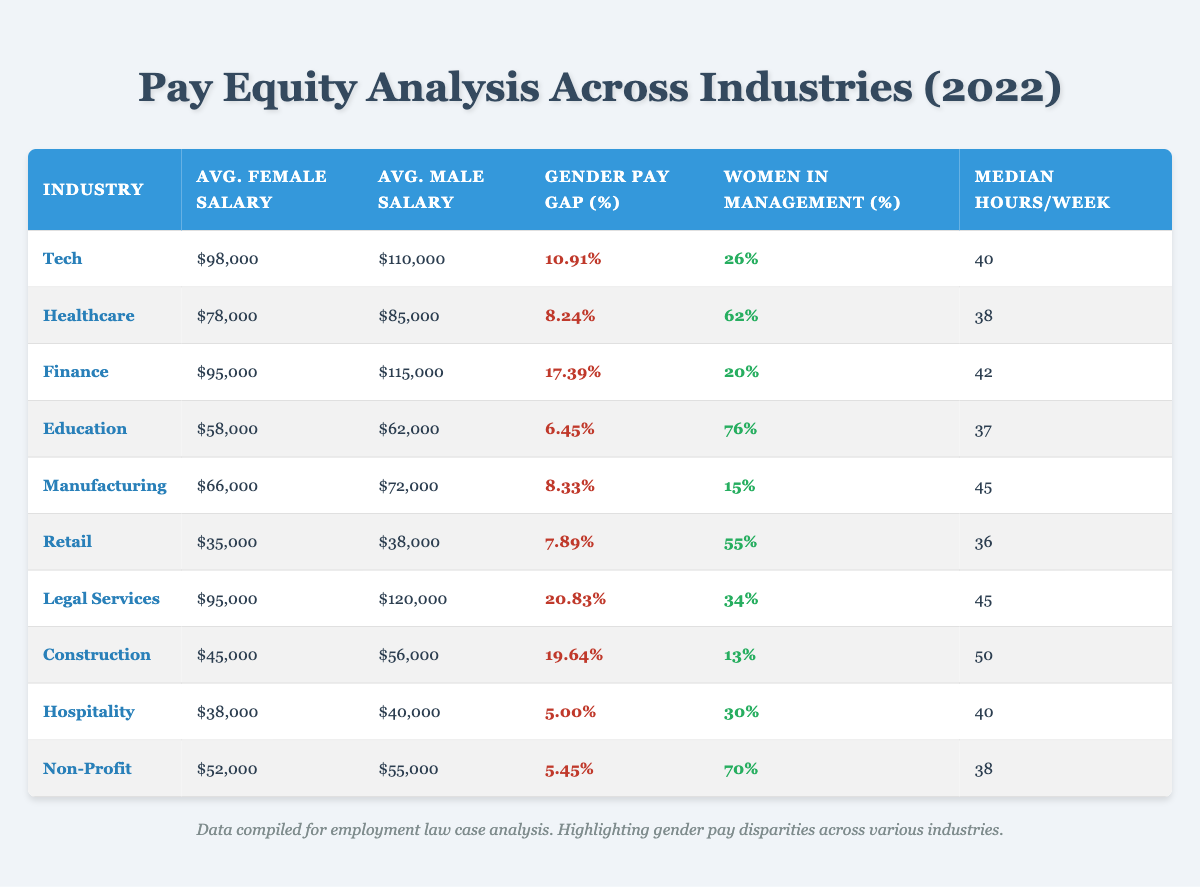What is the gender pay gap percentage in the Finance industry? To find this information, locate the Finance row in the table and read the "Gender Pay Gap (%)" column. The value listed is 17.39% for the Finance industry.
Answer: 17.39% Which industry has the highest percentage of women in management? By comparing the "Women in Management (%)" values across all industries in the table, I find that Education has the highest value at 76%.
Answer: Education How much higher is the average male salary compared to the average female salary in the Tech industry? The average male salary in Tech is 110000, while the average female salary is 98000. Subtract the average female salary from the male salary: 110000 - 98000 = 12000.
Answer: 12000 Is the average female salary in the Legal Services industry higher than that in the Retail industry? The average female salary for Legal Services is 95000, while for Retail, it is 35000. 95000 is greater than 35000, thus making the statement true.
Answer: Yes If we consider the average salaries in Healthcare and Education, what is the percentage difference in their average female salaries? The average female salary for Healthcare is 78000, and for Education, it is 58000. To find the percentage difference, subtract the lower salary from the higher one, divide by the lower one, and multiply by 100: (78000 - 58000) / 58000 * 100 = 34.48%.
Answer: 34.48% Calculate the average gender pay gap percentage of all industries. The gender pay gap percentages are: 10.91, 8.24, 17.39, 6.45, 8.33, 20.83, 19.64, 5.00, and 5.45. I will sum these values: 10.91 + 8.24 + 17.39 + 6.45 + 8.33 + 20.83 + 19.64 + 5.00 + 5.45 =  102.24. There are 9 industries, so I divide the total by 9 to get the average: 102.24 / 9 = 11.36%.
Answer: 11.36% Which industry has the lowest average male salary? By checking the "Average Male Salary" column, I compare all the values. Retail has the lowest average male salary of 38000.
Answer: Retail How many industries have a gender pay gap percentage below 10%? I review the table and count the industries with a gender pay gap percentage less than 10%. The industries are Healthcare (8.24%), Education (6.45%), Manufacturing (8.33%), Retail (7.89%), Hospitality (5%), and Non-Profit (5.45%). This results in a total of 6 industries.
Answer: 6 